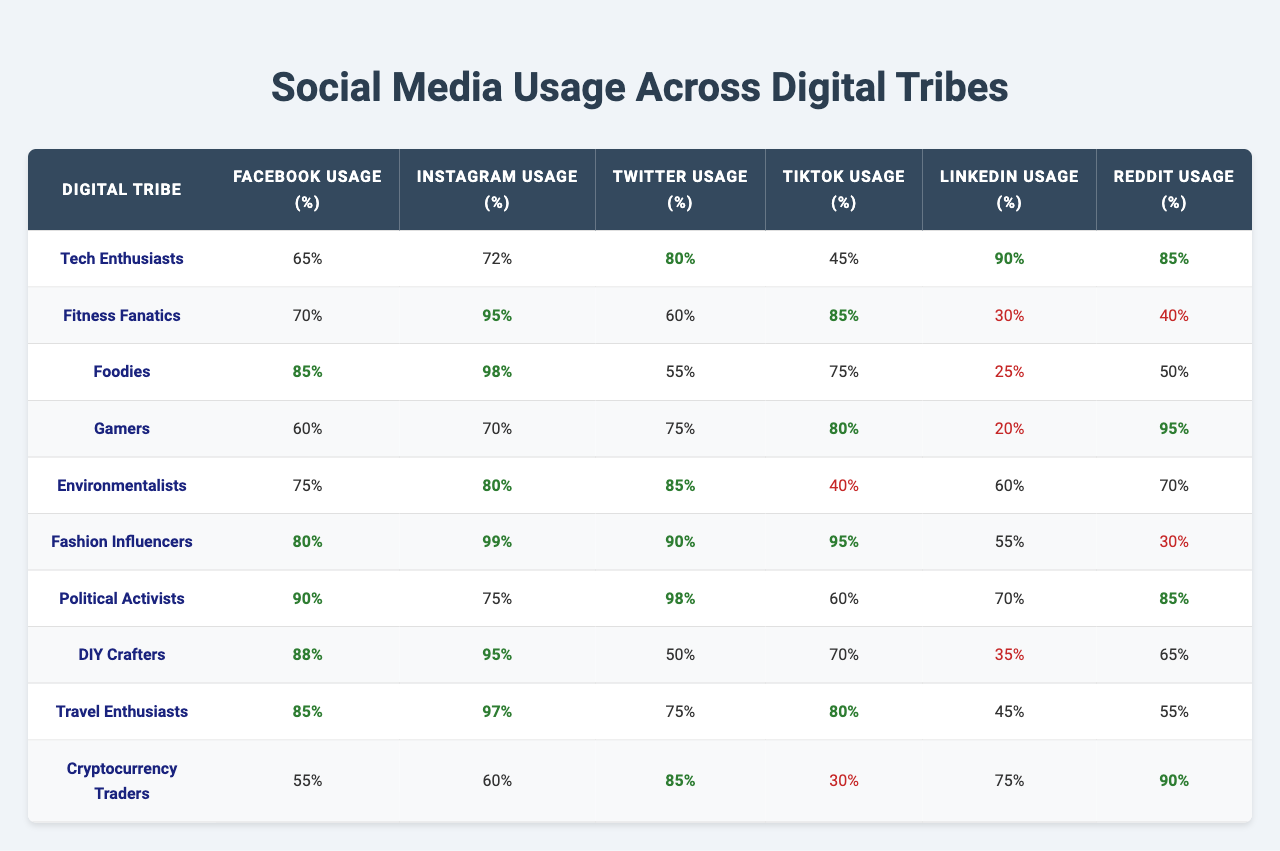What is the Facebook usage percentage of Fashion Influencers? According to the table, the Facebook usage percentage for Fashion Influencers is listed directly in the row corresponding to that tribe.
Answer: 80% Which digital tribe has the highest Instagram usage? By scanning through the Instagram usage percentages, Fashion Influencers have the highest usage at 99%.
Answer: Fashion Influencers What is the average Twitter usage across all digital tribes? To find the average, add all Twitter usage percentages: (80 + 60 + 55 + 75 + 85 + 90 + 98 + 50 + 75 + 85) =  765, and then divide by the number of tribes (10): 765 / 10 = 76.5.
Answer: 76.5% Do Cryptocurrency Traders have higher TikTok usage than Fitness Fanatics? Checking the TikTok usage percentages, Cryptocurrency Traders have 30% and Fitness Fanatics have 85%. Since 30% is less than 85%, the statement is false.
Answer: No Which tribe has the lowest LinkedIn usage? The LinkedIn usage percentages show that Foodies have the lowest at 25%.
Answer: Foodies What is the difference between the Facebook usage of Tech Enthusiasts and Environmentalists? The difference is calculated by subtracting the Facebook usage of Environmentalists (75%) from Tech Enthusiasts (65%): 65% - 75% = -10%. Hence, the Tech Enthusiasts use 10% less than Environmentalists.
Answer: -10% Is it true that Political Activists have above-average usage on all platforms? To check this, we need to compare the Political Activists' usage to the average usage of each platform. After computing the averages for all platforms, we find that Political Activists only exceed the averages for TikTok and LinkedIn, thus the statement is false.
Answer: No What is the total percentage of Facebook and Instagram usage for Travel Enthusiasts? To find the total, add the Facebook usage (85%) and Instagram usage (97%) for Travel Enthusiasts: 85% + 97% = 182%.
Answer: 182% How many tribes have more than 70% usage on Reddit? By reviewing the Reddit usage percentages, we find that Tech Enthusiasts, Gamers, Political Activists, DIY Crafters, and Cryptocurrency Traders all exceed 70%, totaling 5 tribes.
Answer: 5 Which digital tribe has the most balanced usage across all platforms based on the given data? “Balanced usage” can be interpreted as having percentages that are relatively close to each other. Analyzing the values, Gamers display fairly consistent usage between various platforms, with values ranging from 20% to 95%, indicating some balance.
Answer: Gamers 